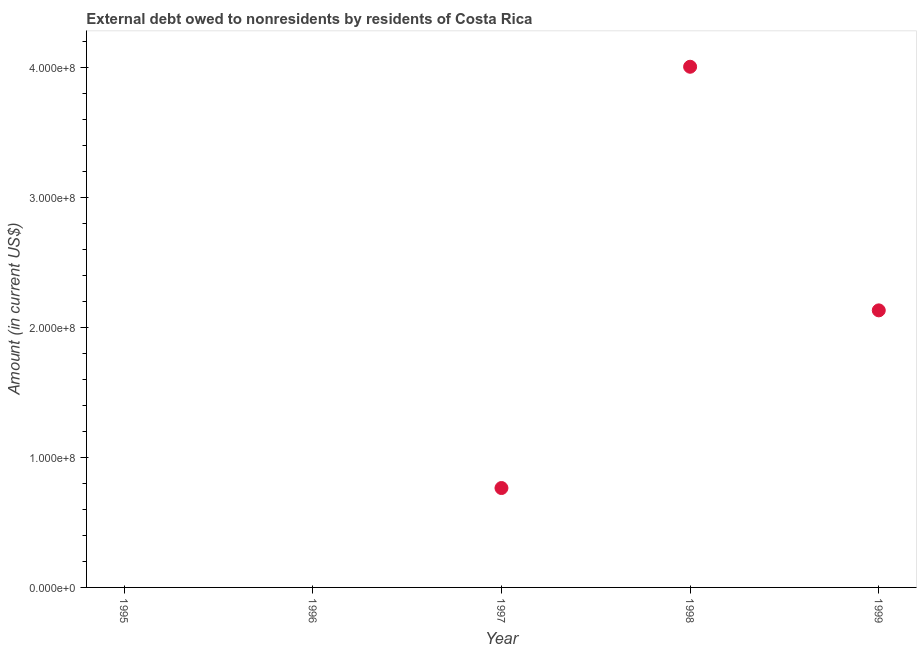What is the debt in 1995?
Make the answer very short. 0. Across all years, what is the maximum debt?
Offer a very short reply. 4.01e+08. Across all years, what is the minimum debt?
Ensure brevity in your answer.  0. What is the sum of the debt?
Make the answer very short. 6.90e+08. What is the difference between the debt in 1997 and 1998?
Keep it short and to the point. -3.24e+08. What is the average debt per year?
Make the answer very short. 1.38e+08. What is the median debt?
Your answer should be very brief. 7.65e+07. In how many years, is the debt greater than 360000000 US$?
Provide a short and direct response. 1. What is the ratio of the debt in 1998 to that in 1999?
Offer a very short reply. 1.88. What is the difference between the highest and the second highest debt?
Your answer should be compact. 1.88e+08. What is the difference between the highest and the lowest debt?
Keep it short and to the point. 4.01e+08. In how many years, is the debt greater than the average debt taken over all years?
Your answer should be compact. 2. Does the debt monotonically increase over the years?
Offer a very short reply. No. What is the difference between two consecutive major ticks on the Y-axis?
Your answer should be compact. 1.00e+08. Are the values on the major ticks of Y-axis written in scientific E-notation?
Offer a very short reply. Yes. Does the graph contain grids?
Keep it short and to the point. No. What is the title of the graph?
Give a very brief answer. External debt owed to nonresidents by residents of Costa Rica. What is the label or title of the X-axis?
Your answer should be very brief. Year. What is the Amount (in current US$) in 1995?
Your answer should be very brief. 0. What is the Amount (in current US$) in 1997?
Provide a succinct answer. 7.65e+07. What is the Amount (in current US$) in 1998?
Your answer should be very brief. 4.01e+08. What is the Amount (in current US$) in 1999?
Keep it short and to the point. 2.13e+08. What is the difference between the Amount (in current US$) in 1997 and 1998?
Offer a terse response. -3.24e+08. What is the difference between the Amount (in current US$) in 1997 and 1999?
Offer a terse response. -1.37e+08. What is the difference between the Amount (in current US$) in 1998 and 1999?
Keep it short and to the point. 1.88e+08. What is the ratio of the Amount (in current US$) in 1997 to that in 1998?
Provide a succinct answer. 0.19. What is the ratio of the Amount (in current US$) in 1997 to that in 1999?
Your response must be concise. 0.36. What is the ratio of the Amount (in current US$) in 1998 to that in 1999?
Offer a very short reply. 1.88. 